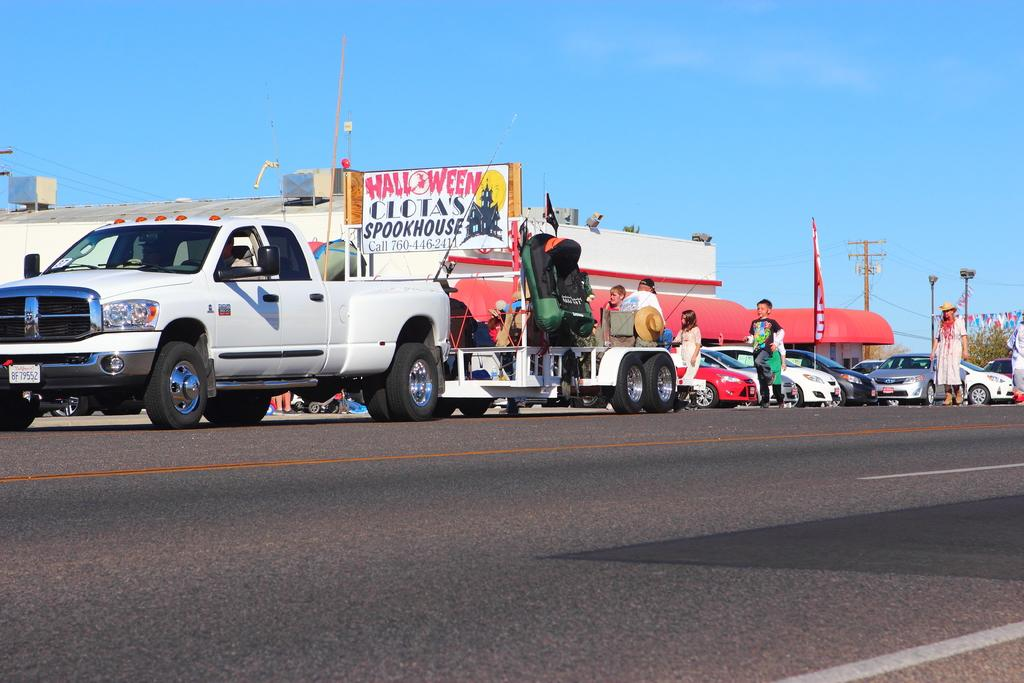What can be seen in the image? There are vehicles and a group of people in the image. What is visible in the background of the image? In the background, there are poles, hoardings, flags, trees, and buildings. How many types of objects can be seen in the background? There are at least six types of objects visible in the background: poles, hoardings, flags, trees, and buildings. Can you tell me how deep the river is in the image? There is no river present in the image; it features vehicles, a group of people, and various objects in the background. What thoughts are going through the minds of the people in the image? The thoughts of the people in the image cannot be determined from the image itself. 